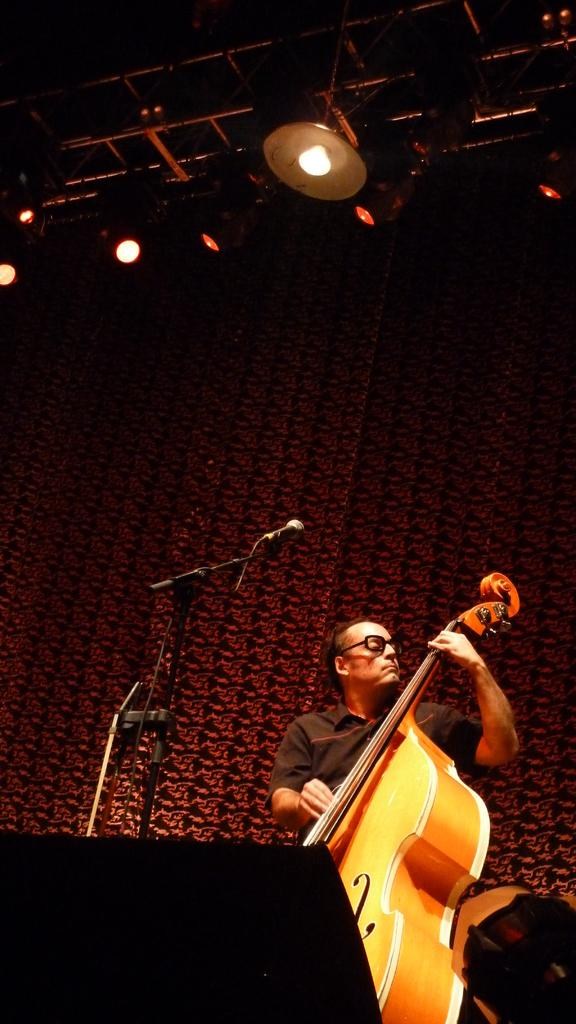What is the man in the image holding? The man is holding a musical instrument. What else can be seen in the image related to music or performance? There is a microphone in the image. What can be seen in the background of the image? There is a light and a curtain in the background of the image. What type of yak can be seen playing the musical instrument in the image? There is no yak present in the image; it features a man holding a musical instrument. What type of wax is being used to create the sound from the musical instrument in the image? There is no wax mentioned or visible in the image; the man is simply holding a musical instrument. 